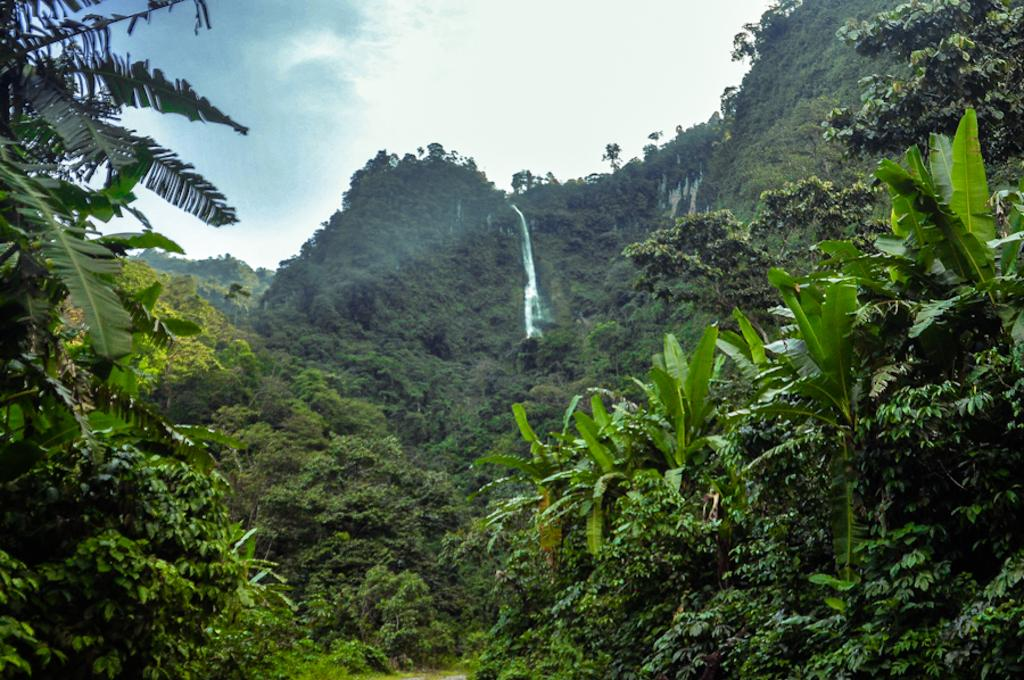What type of vegetation can be seen in the image? There are trees and plants in the image. What natural feature is visible in the background of the image? There is a waterfall in the background of the image. How would you describe the sky in the image? The sky is cloudy in the image. What type of cherry is hanging from the trees in the image? There are no cherries visible in the image; only trees and plants are present. Is there a chain attached to the waterfall in the image? There is no chain present in the image; only the waterfall is visible in the background. 